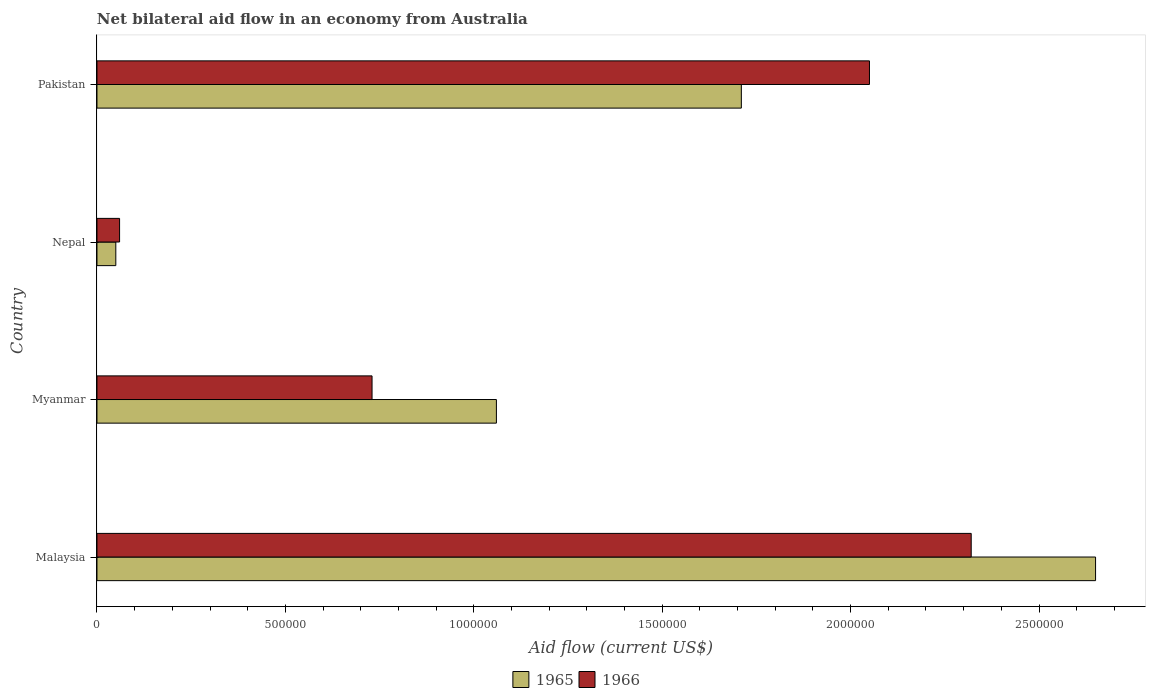How many different coloured bars are there?
Keep it short and to the point. 2. How many groups of bars are there?
Give a very brief answer. 4. Are the number of bars on each tick of the Y-axis equal?
Provide a short and direct response. Yes. How many bars are there on the 1st tick from the top?
Offer a very short reply. 2. What is the label of the 1st group of bars from the top?
Provide a succinct answer. Pakistan. What is the net bilateral aid flow in 1965 in Pakistan?
Your response must be concise. 1.71e+06. Across all countries, what is the maximum net bilateral aid flow in 1965?
Provide a short and direct response. 2.65e+06. Across all countries, what is the minimum net bilateral aid flow in 1965?
Give a very brief answer. 5.00e+04. In which country was the net bilateral aid flow in 1965 maximum?
Offer a terse response. Malaysia. In which country was the net bilateral aid flow in 1965 minimum?
Offer a terse response. Nepal. What is the total net bilateral aid flow in 1965 in the graph?
Your response must be concise. 5.47e+06. What is the difference between the net bilateral aid flow in 1966 in Nepal and that in Pakistan?
Your answer should be compact. -1.99e+06. What is the difference between the net bilateral aid flow in 1965 in Nepal and the net bilateral aid flow in 1966 in Myanmar?
Provide a succinct answer. -6.80e+05. What is the average net bilateral aid flow in 1966 per country?
Keep it short and to the point. 1.29e+06. What is the ratio of the net bilateral aid flow in 1966 in Malaysia to that in Nepal?
Make the answer very short. 38.67. Is the difference between the net bilateral aid flow in 1965 in Nepal and Pakistan greater than the difference between the net bilateral aid flow in 1966 in Nepal and Pakistan?
Keep it short and to the point. Yes. What is the difference between the highest and the second highest net bilateral aid flow in 1966?
Keep it short and to the point. 2.70e+05. What is the difference between the highest and the lowest net bilateral aid flow in 1966?
Your answer should be compact. 2.26e+06. In how many countries, is the net bilateral aid flow in 1966 greater than the average net bilateral aid flow in 1966 taken over all countries?
Ensure brevity in your answer.  2. What does the 1st bar from the top in Myanmar represents?
Provide a succinct answer. 1966. What does the 1st bar from the bottom in Pakistan represents?
Offer a terse response. 1965. How many bars are there?
Ensure brevity in your answer.  8. Are all the bars in the graph horizontal?
Offer a very short reply. Yes. How many countries are there in the graph?
Give a very brief answer. 4. What is the difference between two consecutive major ticks on the X-axis?
Keep it short and to the point. 5.00e+05. Does the graph contain any zero values?
Provide a short and direct response. No. Does the graph contain grids?
Offer a terse response. No. Where does the legend appear in the graph?
Provide a succinct answer. Bottom center. How many legend labels are there?
Provide a succinct answer. 2. What is the title of the graph?
Keep it short and to the point. Net bilateral aid flow in an economy from Australia. Does "2012" appear as one of the legend labels in the graph?
Offer a terse response. No. What is the label or title of the X-axis?
Your answer should be very brief. Aid flow (current US$). What is the label or title of the Y-axis?
Keep it short and to the point. Country. What is the Aid flow (current US$) in 1965 in Malaysia?
Offer a very short reply. 2.65e+06. What is the Aid flow (current US$) in 1966 in Malaysia?
Provide a succinct answer. 2.32e+06. What is the Aid flow (current US$) of 1965 in Myanmar?
Offer a very short reply. 1.06e+06. What is the Aid flow (current US$) of 1966 in Myanmar?
Give a very brief answer. 7.30e+05. What is the Aid flow (current US$) of 1966 in Nepal?
Your answer should be compact. 6.00e+04. What is the Aid flow (current US$) in 1965 in Pakistan?
Your answer should be compact. 1.71e+06. What is the Aid flow (current US$) in 1966 in Pakistan?
Your answer should be very brief. 2.05e+06. Across all countries, what is the maximum Aid flow (current US$) of 1965?
Offer a terse response. 2.65e+06. Across all countries, what is the maximum Aid flow (current US$) of 1966?
Offer a very short reply. 2.32e+06. Across all countries, what is the minimum Aid flow (current US$) of 1965?
Your response must be concise. 5.00e+04. What is the total Aid flow (current US$) in 1965 in the graph?
Your answer should be compact. 5.47e+06. What is the total Aid flow (current US$) of 1966 in the graph?
Your answer should be very brief. 5.16e+06. What is the difference between the Aid flow (current US$) of 1965 in Malaysia and that in Myanmar?
Your answer should be very brief. 1.59e+06. What is the difference between the Aid flow (current US$) in 1966 in Malaysia and that in Myanmar?
Offer a terse response. 1.59e+06. What is the difference between the Aid flow (current US$) in 1965 in Malaysia and that in Nepal?
Your response must be concise. 2.60e+06. What is the difference between the Aid flow (current US$) in 1966 in Malaysia and that in Nepal?
Your answer should be very brief. 2.26e+06. What is the difference between the Aid flow (current US$) of 1965 in Malaysia and that in Pakistan?
Provide a succinct answer. 9.40e+05. What is the difference between the Aid flow (current US$) in 1966 in Malaysia and that in Pakistan?
Provide a succinct answer. 2.70e+05. What is the difference between the Aid flow (current US$) of 1965 in Myanmar and that in Nepal?
Give a very brief answer. 1.01e+06. What is the difference between the Aid flow (current US$) of 1966 in Myanmar and that in Nepal?
Your answer should be compact. 6.70e+05. What is the difference between the Aid flow (current US$) in 1965 in Myanmar and that in Pakistan?
Keep it short and to the point. -6.50e+05. What is the difference between the Aid flow (current US$) in 1966 in Myanmar and that in Pakistan?
Offer a very short reply. -1.32e+06. What is the difference between the Aid flow (current US$) in 1965 in Nepal and that in Pakistan?
Offer a very short reply. -1.66e+06. What is the difference between the Aid flow (current US$) of 1966 in Nepal and that in Pakistan?
Provide a succinct answer. -1.99e+06. What is the difference between the Aid flow (current US$) of 1965 in Malaysia and the Aid flow (current US$) of 1966 in Myanmar?
Make the answer very short. 1.92e+06. What is the difference between the Aid flow (current US$) in 1965 in Malaysia and the Aid flow (current US$) in 1966 in Nepal?
Your answer should be very brief. 2.59e+06. What is the difference between the Aid flow (current US$) of 1965 in Myanmar and the Aid flow (current US$) of 1966 in Nepal?
Your answer should be very brief. 1.00e+06. What is the difference between the Aid flow (current US$) of 1965 in Myanmar and the Aid flow (current US$) of 1966 in Pakistan?
Give a very brief answer. -9.90e+05. What is the difference between the Aid flow (current US$) of 1965 in Nepal and the Aid flow (current US$) of 1966 in Pakistan?
Your answer should be compact. -2.00e+06. What is the average Aid flow (current US$) in 1965 per country?
Provide a succinct answer. 1.37e+06. What is the average Aid flow (current US$) in 1966 per country?
Provide a succinct answer. 1.29e+06. What is the difference between the Aid flow (current US$) in 1965 and Aid flow (current US$) in 1966 in Malaysia?
Provide a short and direct response. 3.30e+05. What is the difference between the Aid flow (current US$) of 1965 and Aid flow (current US$) of 1966 in Myanmar?
Your response must be concise. 3.30e+05. What is the difference between the Aid flow (current US$) in 1965 and Aid flow (current US$) in 1966 in Nepal?
Your answer should be very brief. -10000. What is the ratio of the Aid flow (current US$) of 1966 in Malaysia to that in Myanmar?
Your answer should be compact. 3.18. What is the ratio of the Aid flow (current US$) of 1966 in Malaysia to that in Nepal?
Your answer should be compact. 38.67. What is the ratio of the Aid flow (current US$) of 1965 in Malaysia to that in Pakistan?
Provide a succinct answer. 1.55. What is the ratio of the Aid flow (current US$) of 1966 in Malaysia to that in Pakistan?
Your answer should be very brief. 1.13. What is the ratio of the Aid flow (current US$) in 1965 in Myanmar to that in Nepal?
Keep it short and to the point. 21.2. What is the ratio of the Aid flow (current US$) in 1966 in Myanmar to that in Nepal?
Offer a very short reply. 12.17. What is the ratio of the Aid flow (current US$) of 1965 in Myanmar to that in Pakistan?
Give a very brief answer. 0.62. What is the ratio of the Aid flow (current US$) in 1966 in Myanmar to that in Pakistan?
Offer a very short reply. 0.36. What is the ratio of the Aid flow (current US$) of 1965 in Nepal to that in Pakistan?
Provide a succinct answer. 0.03. What is the ratio of the Aid flow (current US$) in 1966 in Nepal to that in Pakistan?
Ensure brevity in your answer.  0.03. What is the difference between the highest and the second highest Aid flow (current US$) in 1965?
Your answer should be compact. 9.40e+05. What is the difference between the highest and the second highest Aid flow (current US$) of 1966?
Keep it short and to the point. 2.70e+05. What is the difference between the highest and the lowest Aid flow (current US$) in 1965?
Offer a very short reply. 2.60e+06. What is the difference between the highest and the lowest Aid flow (current US$) of 1966?
Your response must be concise. 2.26e+06. 